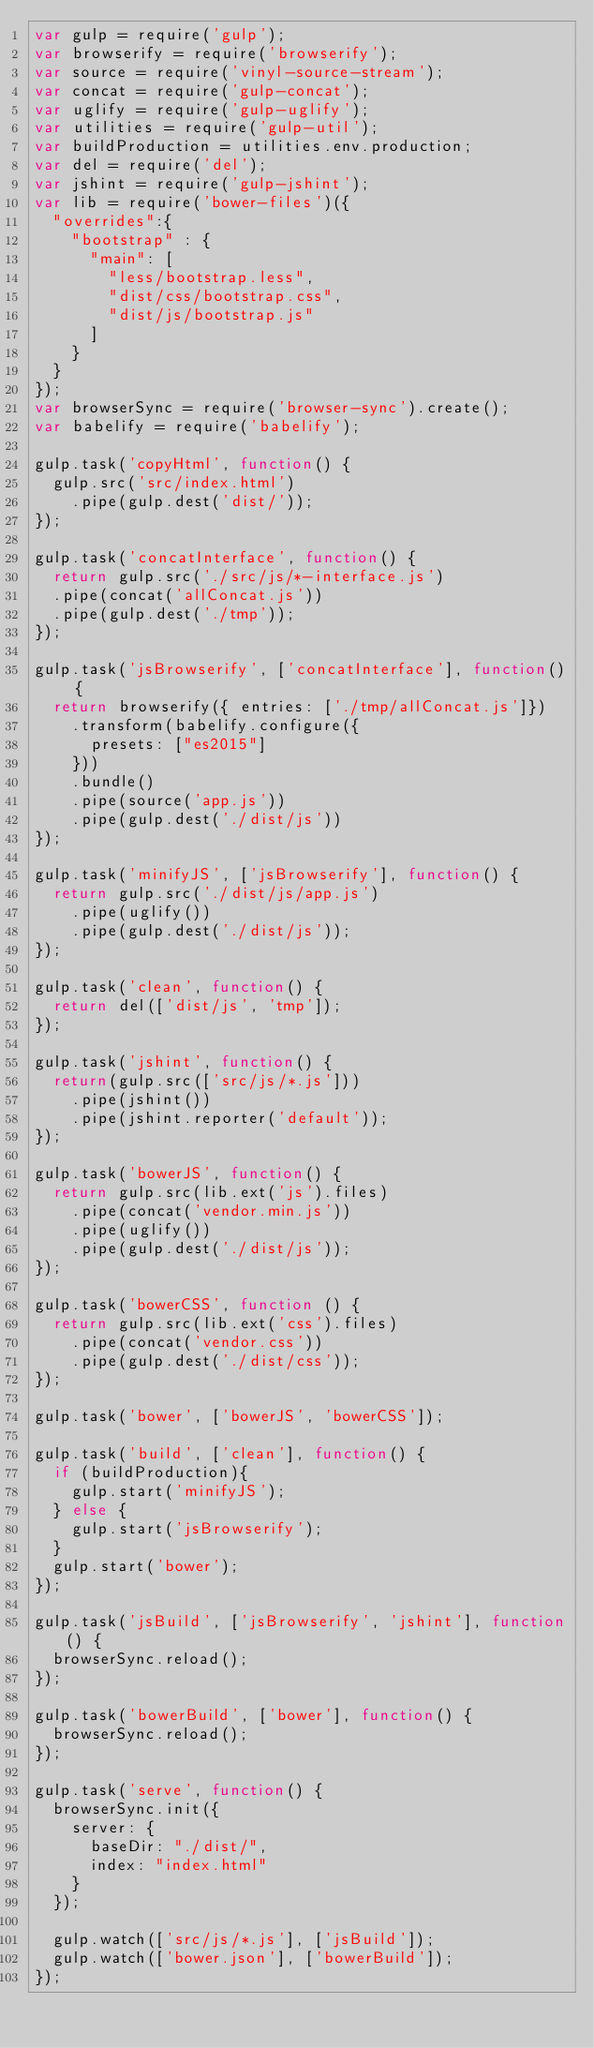Convert code to text. <code><loc_0><loc_0><loc_500><loc_500><_JavaScript_>var gulp = require('gulp');
var browserify = require('browserify');
var source = require('vinyl-source-stream');
var concat = require('gulp-concat');
var uglify = require('gulp-uglify');
var utilities = require('gulp-util');
var buildProduction = utilities.env.production;
var del = require('del');
var jshint = require('gulp-jshint');
var lib = require('bower-files')({
  "overrides":{
    "bootstrap" : {
      "main": [
        "less/bootstrap.less",
        "dist/css/bootstrap.css",
        "dist/js/bootstrap.js"
      ]
    }
  }
});
var browserSync = require('browser-sync').create();
var babelify = require('babelify');

gulp.task('copyHtml', function() {
  gulp.src('src/index.html')
    .pipe(gulp.dest('dist/'));
});

gulp.task('concatInterface', function() {
  return gulp.src('./src/js/*-interface.js')
  .pipe(concat('allConcat.js'))
  .pipe(gulp.dest('./tmp'));
});

gulp.task('jsBrowserify', ['concatInterface'], function() {
  return browserify({ entries: ['./tmp/allConcat.js']})
    .transform(babelify.configure({
      presets: ["es2015"]
    }))
    .bundle()
    .pipe(source('app.js'))
    .pipe(gulp.dest('./dist/js'))
});

gulp.task('minifyJS', ['jsBrowserify'], function() {
  return gulp.src('./dist/js/app.js')
    .pipe(uglify())
    .pipe(gulp.dest('./dist/js'));
});

gulp.task('clean', function() {
  return del(['dist/js', 'tmp']);
});

gulp.task('jshint', function() {
  return(gulp.src(['src/js/*.js']))
    .pipe(jshint())
    .pipe(jshint.reporter('default'));
});

gulp.task('bowerJS', function() {
  return gulp.src(lib.ext('js').files)
    .pipe(concat('vendor.min.js'))
    .pipe(uglify())
    .pipe(gulp.dest('./dist/js'));
});

gulp.task('bowerCSS', function () {
  return gulp.src(lib.ext('css').files)
    .pipe(concat('vendor.css'))
    .pipe(gulp.dest('./dist/css'));
});

gulp.task('bower', ['bowerJS', 'bowerCSS']);

gulp.task('build', ['clean'], function() {
  if (buildProduction){
    gulp.start('minifyJS');
  } else {
    gulp.start('jsBrowserify');
  }
  gulp.start('bower');
});

gulp.task('jsBuild', ['jsBrowserify', 'jshint'], function() {
  browserSync.reload();
});

gulp.task('bowerBuild', ['bower'], function() {
  browserSync.reload();
});

gulp.task('serve', function() {
  browserSync.init({
    server: {
      baseDir: "./dist/",
      index: "index.html"
    }
  });

  gulp.watch(['src/js/*.js'], ['jsBuild']);
  gulp.watch(['bower.json'], ['bowerBuild']);
});
</code> 